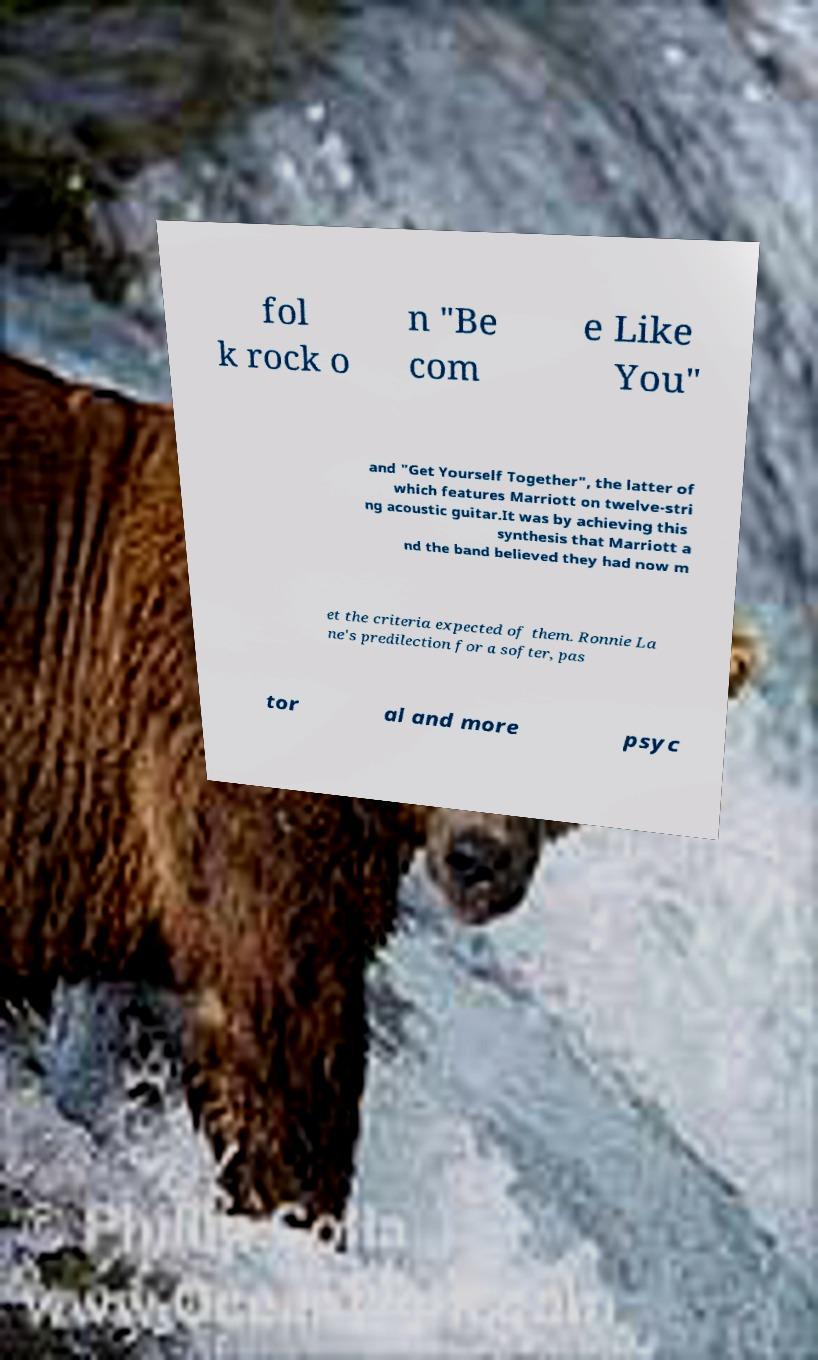Please read and relay the text visible in this image. What does it say? fol k rock o n "Be com e Like You" and "Get Yourself Together", the latter of which features Marriott on twelve-stri ng acoustic guitar.It was by achieving this synthesis that Marriott a nd the band believed they had now m et the criteria expected of them. Ronnie La ne's predilection for a softer, pas tor al and more psyc 